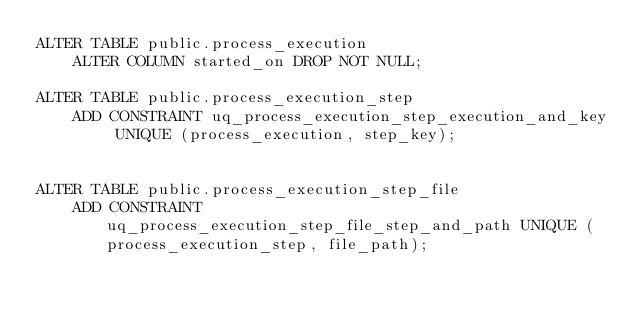<code> <loc_0><loc_0><loc_500><loc_500><_SQL_>ALTER TABLE public.process_execution 
    ALTER COLUMN started_on DROP NOT NULL;

ALTER TABLE public.process_execution_step
    ADD CONSTRAINT uq_process_execution_step_execution_and_key UNIQUE (process_execution, step_key);


ALTER TABLE public.process_execution_step_file
    ADD CONSTRAINT uq_process_execution_step_file_step_and_path UNIQUE (process_execution_step, file_path);
</code> 